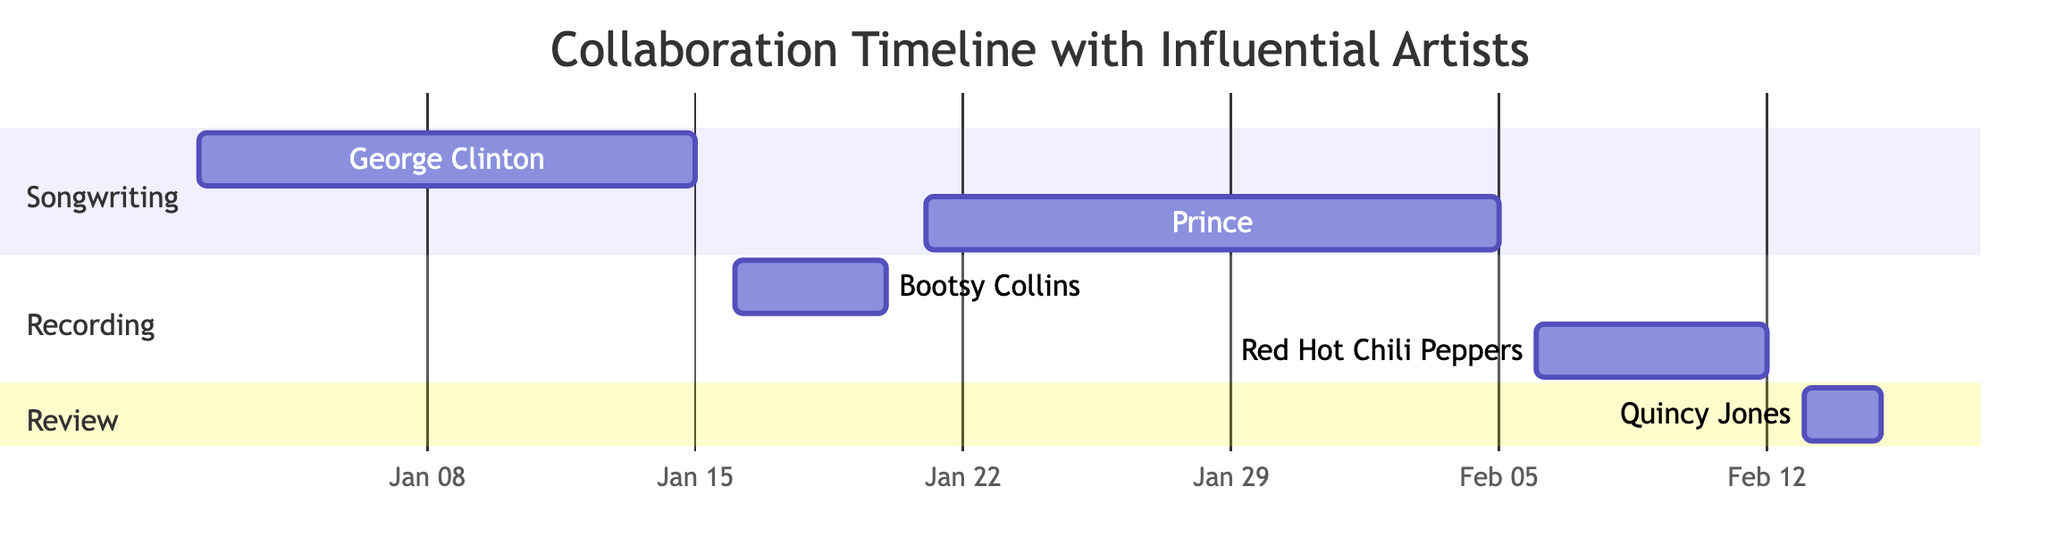What is the starting date for the songwriting session with George Clinton? According to the diagram, the task "Songwriting Session with George Clinton" begins on the date "2023-01-02".
Answer: 2023-01-02 How many recording meetings are depicted in the chart? The diagram shows two tasks in the "Recording" section: one with Bootsy Collins and the other with Red Hot Chili Peppers, totaling two recording meetings.
Answer: 2 What is the end date of the final review with Quincy Jones? The chart indicates that the "Final Review with Quincy Jones" task concludes on "2023-02-15".
Answer: 2023-02-15 Which artist's songwriting session occurs right after the recording meeting with Bootsy Collins? On analyzing the timeline, the "Songwriting Session with Prince" occurs directly after the "Recording Meeting with Bootsy Collins", starting on "2023-01-21".
Answer: Prince What task spans the longest duration within the timeline? By comparing the durations of each task, the "Songwriting Session with Prince" lasts from "2023-01-21" to "2023-02-05", totaling 16 days, which is the longest of all tasks.
Answer: Songwriting Session with Prince Which two sections of the Gantt chart include tasks that overlap in the timeline? The sections for "Songwriting" and "Recording" have tasks that overlap in terms of dates. Specifically, the end of the songwriting session with George Clinton overlaps with the beginning of the recording meeting with Bootsy Collins.
Answer: Songwriting, Recording What is the total number of tasks outlined in the Gantt chart? Counting all the tasks listed in the sections of the Gantt chart, there are five tasks: two in "Songwriting," two in "Recording," and one in "Review." Hence, the total is five tasks.
Answer: 5 When does the recording meeting with Red Hot Chili Peppers start? The diagram specifies that the "Recording Meeting with Red Hot Chili Peppers" starts on "2023-02-06".
Answer: 2023-02-06 Which task follows immediately after the songwriting session with George Clinton? The "Recording Meeting with Bootsy Collins" follows immediately after the "Songwriting Session with George Clinton," starting on "2023-01-16".
Answer: Recording Meeting with Bootsy Collins 